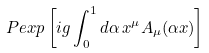<formula> <loc_0><loc_0><loc_500><loc_500>P e x p \left [ i g \int _ { 0 } ^ { 1 } d \alpha \, x ^ { \mu } A _ { \mu } ( \alpha x ) \right ]</formula> 